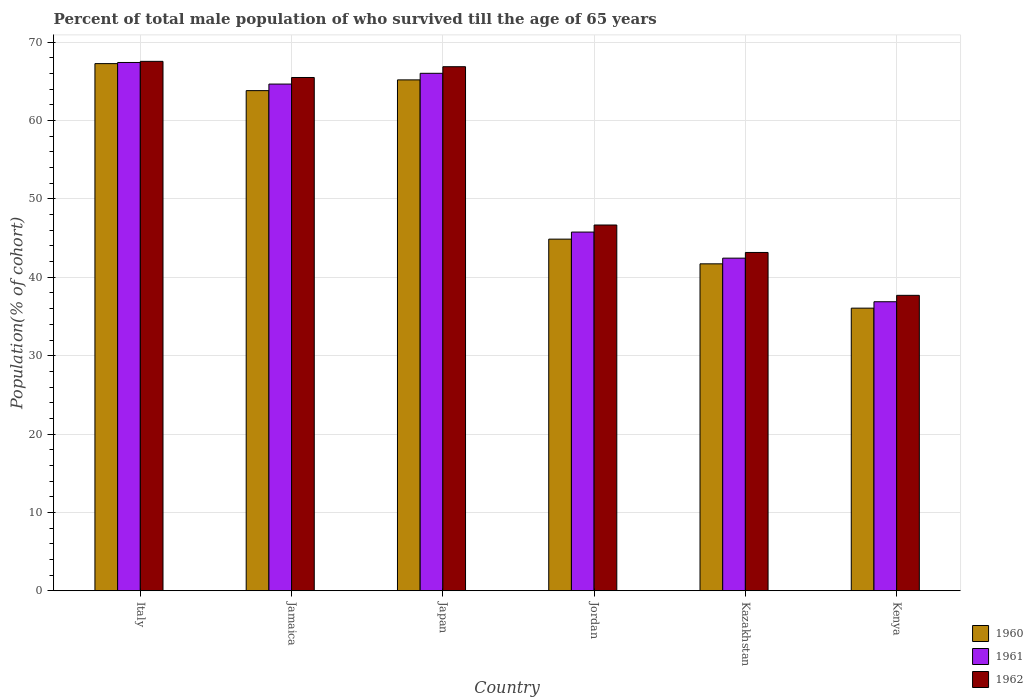Are the number of bars per tick equal to the number of legend labels?
Your response must be concise. Yes. How many bars are there on the 5th tick from the left?
Give a very brief answer. 3. How many bars are there on the 2nd tick from the right?
Provide a succinct answer. 3. What is the label of the 5th group of bars from the left?
Give a very brief answer. Kazakhstan. What is the percentage of total male population who survived till the age of 65 years in 1961 in Jamaica?
Keep it short and to the point. 64.67. Across all countries, what is the maximum percentage of total male population who survived till the age of 65 years in 1961?
Your response must be concise. 67.42. Across all countries, what is the minimum percentage of total male population who survived till the age of 65 years in 1961?
Give a very brief answer. 36.88. In which country was the percentage of total male population who survived till the age of 65 years in 1960 maximum?
Offer a terse response. Italy. In which country was the percentage of total male population who survived till the age of 65 years in 1962 minimum?
Offer a very short reply. Kenya. What is the total percentage of total male population who survived till the age of 65 years in 1960 in the graph?
Provide a succinct answer. 318.97. What is the difference between the percentage of total male population who survived till the age of 65 years in 1961 in Jordan and that in Kazakhstan?
Provide a succinct answer. 3.33. What is the difference between the percentage of total male population who survived till the age of 65 years in 1962 in Jordan and the percentage of total male population who survived till the age of 65 years in 1960 in Jamaica?
Ensure brevity in your answer.  -17.15. What is the average percentage of total male population who survived till the age of 65 years in 1961 per country?
Offer a very short reply. 53.87. What is the difference between the percentage of total male population who survived till the age of 65 years of/in 1961 and percentage of total male population who survived till the age of 65 years of/in 1962 in Jamaica?
Provide a succinct answer. -0.84. What is the ratio of the percentage of total male population who survived till the age of 65 years in 1962 in Jamaica to that in Kenya?
Your response must be concise. 1.74. Is the percentage of total male population who survived till the age of 65 years in 1960 in Italy less than that in Kazakhstan?
Your answer should be very brief. No. What is the difference between the highest and the second highest percentage of total male population who survived till the age of 65 years in 1962?
Give a very brief answer. -1.38. What is the difference between the highest and the lowest percentage of total male population who survived till the age of 65 years in 1960?
Provide a succinct answer. 31.21. In how many countries, is the percentage of total male population who survived till the age of 65 years in 1960 greater than the average percentage of total male population who survived till the age of 65 years in 1960 taken over all countries?
Keep it short and to the point. 3. Is the sum of the percentage of total male population who survived till the age of 65 years in 1960 in Italy and Jordan greater than the maximum percentage of total male population who survived till the age of 65 years in 1962 across all countries?
Your answer should be compact. Yes. What does the 3rd bar from the right in Kenya represents?
Ensure brevity in your answer.  1960. Is it the case that in every country, the sum of the percentage of total male population who survived till the age of 65 years in 1961 and percentage of total male population who survived till the age of 65 years in 1962 is greater than the percentage of total male population who survived till the age of 65 years in 1960?
Ensure brevity in your answer.  Yes. What is the difference between two consecutive major ticks on the Y-axis?
Give a very brief answer. 10. Are the values on the major ticks of Y-axis written in scientific E-notation?
Offer a very short reply. No. Does the graph contain any zero values?
Give a very brief answer. No. Does the graph contain grids?
Your response must be concise. Yes. How many legend labels are there?
Ensure brevity in your answer.  3. How are the legend labels stacked?
Give a very brief answer. Vertical. What is the title of the graph?
Offer a very short reply. Percent of total male population of who survived till the age of 65 years. What is the label or title of the Y-axis?
Offer a very short reply. Population(% of cohort). What is the Population(% of cohort) in 1960 in Italy?
Give a very brief answer. 67.28. What is the Population(% of cohort) in 1961 in Italy?
Keep it short and to the point. 67.42. What is the Population(% of cohort) of 1962 in Italy?
Your answer should be compact. 67.57. What is the Population(% of cohort) of 1960 in Jamaica?
Ensure brevity in your answer.  63.83. What is the Population(% of cohort) of 1961 in Jamaica?
Make the answer very short. 64.67. What is the Population(% of cohort) in 1962 in Jamaica?
Your answer should be very brief. 65.5. What is the Population(% of cohort) in 1960 in Japan?
Ensure brevity in your answer.  65.2. What is the Population(% of cohort) of 1961 in Japan?
Keep it short and to the point. 66.04. What is the Population(% of cohort) of 1962 in Japan?
Make the answer very short. 66.88. What is the Population(% of cohort) of 1960 in Jordan?
Offer a very short reply. 44.87. What is the Population(% of cohort) of 1961 in Jordan?
Ensure brevity in your answer.  45.78. What is the Population(% of cohort) of 1962 in Jordan?
Ensure brevity in your answer.  46.68. What is the Population(% of cohort) in 1960 in Kazakhstan?
Offer a terse response. 41.72. What is the Population(% of cohort) in 1961 in Kazakhstan?
Provide a short and direct response. 42.45. What is the Population(% of cohort) of 1962 in Kazakhstan?
Give a very brief answer. 43.17. What is the Population(% of cohort) in 1960 in Kenya?
Provide a succinct answer. 36.07. What is the Population(% of cohort) of 1961 in Kenya?
Provide a succinct answer. 36.88. What is the Population(% of cohort) of 1962 in Kenya?
Your response must be concise. 37.7. Across all countries, what is the maximum Population(% of cohort) in 1960?
Ensure brevity in your answer.  67.28. Across all countries, what is the maximum Population(% of cohort) of 1961?
Give a very brief answer. 67.42. Across all countries, what is the maximum Population(% of cohort) in 1962?
Offer a very short reply. 67.57. Across all countries, what is the minimum Population(% of cohort) in 1960?
Make the answer very short. 36.07. Across all countries, what is the minimum Population(% of cohort) of 1961?
Your answer should be very brief. 36.88. Across all countries, what is the minimum Population(% of cohort) in 1962?
Offer a terse response. 37.7. What is the total Population(% of cohort) in 1960 in the graph?
Your answer should be very brief. 318.97. What is the total Population(% of cohort) in 1961 in the graph?
Offer a terse response. 323.23. What is the total Population(% of cohort) of 1962 in the graph?
Your answer should be very brief. 327.5. What is the difference between the Population(% of cohort) of 1960 in Italy and that in Jamaica?
Ensure brevity in your answer.  3.45. What is the difference between the Population(% of cohort) of 1961 in Italy and that in Jamaica?
Give a very brief answer. 2.75. What is the difference between the Population(% of cohort) of 1962 in Italy and that in Jamaica?
Your answer should be compact. 2.06. What is the difference between the Population(% of cohort) of 1960 in Italy and that in Japan?
Keep it short and to the point. 2.08. What is the difference between the Population(% of cohort) of 1961 in Italy and that in Japan?
Offer a terse response. 1.38. What is the difference between the Population(% of cohort) in 1962 in Italy and that in Japan?
Ensure brevity in your answer.  0.68. What is the difference between the Population(% of cohort) in 1960 in Italy and that in Jordan?
Your answer should be compact. 22.4. What is the difference between the Population(% of cohort) in 1961 in Italy and that in Jordan?
Offer a very short reply. 21.64. What is the difference between the Population(% of cohort) in 1962 in Italy and that in Jordan?
Give a very brief answer. 20.89. What is the difference between the Population(% of cohort) in 1960 in Italy and that in Kazakhstan?
Keep it short and to the point. 25.55. What is the difference between the Population(% of cohort) in 1961 in Italy and that in Kazakhstan?
Keep it short and to the point. 24.97. What is the difference between the Population(% of cohort) of 1962 in Italy and that in Kazakhstan?
Ensure brevity in your answer.  24.39. What is the difference between the Population(% of cohort) in 1960 in Italy and that in Kenya?
Provide a succinct answer. 31.21. What is the difference between the Population(% of cohort) in 1961 in Italy and that in Kenya?
Provide a short and direct response. 30.54. What is the difference between the Population(% of cohort) in 1962 in Italy and that in Kenya?
Provide a short and direct response. 29.86. What is the difference between the Population(% of cohort) of 1960 in Jamaica and that in Japan?
Provide a succinct answer. -1.37. What is the difference between the Population(% of cohort) of 1961 in Jamaica and that in Japan?
Keep it short and to the point. -1.37. What is the difference between the Population(% of cohort) of 1962 in Jamaica and that in Japan?
Ensure brevity in your answer.  -1.38. What is the difference between the Population(% of cohort) in 1960 in Jamaica and that in Jordan?
Make the answer very short. 18.95. What is the difference between the Population(% of cohort) in 1961 in Jamaica and that in Jordan?
Provide a short and direct response. 18.89. What is the difference between the Population(% of cohort) in 1962 in Jamaica and that in Jordan?
Give a very brief answer. 18.83. What is the difference between the Population(% of cohort) of 1960 in Jamaica and that in Kazakhstan?
Offer a terse response. 22.11. What is the difference between the Population(% of cohort) in 1961 in Jamaica and that in Kazakhstan?
Offer a terse response. 22.22. What is the difference between the Population(% of cohort) in 1962 in Jamaica and that in Kazakhstan?
Ensure brevity in your answer.  22.33. What is the difference between the Population(% of cohort) in 1960 in Jamaica and that in Kenya?
Ensure brevity in your answer.  27.76. What is the difference between the Population(% of cohort) of 1961 in Jamaica and that in Kenya?
Offer a terse response. 27.78. What is the difference between the Population(% of cohort) of 1962 in Jamaica and that in Kenya?
Give a very brief answer. 27.8. What is the difference between the Population(% of cohort) of 1960 in Japan and that in Jordan?
Provide a short and direct response. 20.32. What is the difference between the Population(% of cohort) in 1961 in Japan and that in Jordan?
Give a very brief answer. 20.26. What is the difference between the Population(% of cohort) of 1962 in Japan and that in Jordan?
Your answer should be very brief. 20.2. What is the difference between the Population(% of cohort) in 1960 in Japan and that in Kazakhstan?
Ensure brevity in your answer.  23.48. What is the difference between the Population(% of cohort) in 1961 in Japan and that in Kazakhstan?
Your answer should be very brief. 23.59. What is the difference between the Population(% of cohort) in 1962 in Japan and that in Kazakhstan?
Your response must be concise. 23.71. What is the difference between the Population(% of cohort) in 1960 in Japan and that in Kenya?
Give a very brief answer. 29.13. What is the difference between the Population(% of cohort) in 1961 in Japan and that in Kenya?
Your answer should be very brief. 29.16. What is the difference between the Population(% of cohort) of 1962 in Japan and that in Kenya?
Your response must be concise. 29.18. What is the difference between the Population(% of cohort) in 1960 in Jordan and that in Kazakhstan?
Make the answer very short. 3.15. What is the difference between the Population(% of cohort) in 1961 in Jordan and that in Kazakhstan?
Your answer should be very brief. 3.33. What is the difference between the Population(% of cohort) in 1962 in Jordan and that in Kazakhstan?
Provide a short and direct response. 3.51. What is the difference between the Population(% of cohort) of 1960 in Jordan and that in Kenya?
Provide a succinct answer. 8.81. What is the difference between the Population(% of cohort) of 1961 in Jordan and that in Kenya?
Your response must be concise. 8.89. What is the difference between the Population(% of cohort) in 1962 in Jordan and that in Kenya?
Provide a succinct answer. 8.98. What is the difference between the Population(% of cohort) of 1960 in Kazakhstan and that in Kenya?
Keep it short and to the point. 5.66. What is the difference between the Population(% of cohort) of 1961 in Kazakhstan and that in Kenya?
Provide a short and direct response. 5.56. What is the difference between the Population(% of cohort) of 1962 in Kazakhstan and that in Kenya?
Offer a very short reply. 5.47. What is the difference between the Population(% of cohort) in 1960 in Italy and the Population(% of cohort) in 1961 in Jamaica?
Make the answer very short. 2.61. What is the difference between the Population(% of cohort) of 1960 in Italy and the Population(% of cohort) of 1962 in Jamaica?
Ensure brevity in your answer.  1.77. What is the difference between the Population(% of cohort) of 1961 in Italy and the Population(% of cohort) of 1962 in Jamaica?
Your response must be concise. 1.92. What is the difference between the Population(% of cohort) of 1960 in Italy and the Population(% of cohort) of 1961 in Japan?
Provide a succinct answer. 1.24. What is the difference between the Population(% of cohort) of 1960 in Italy and the Population(% of cohort) of 1962 in Japan?
Make the answer very short. 0.4. What is the difference between the Population(% of cohort) of 1961 in Italy and the Population(% of cohort) of 1962 in Japan?
Give a very brief answer. 0.54. What is the difference between the Population(% of cohort) of 1960 in Italy and the Population(% of cohort) of 1961 in Jordan?
Your answer should be very brief. 21.5. What is the difference between the Population(% of cohort) in 1960 in Italy and the Population(% of cohort) in 1962 in Jordan?
Provide a succinct answer. 20.6. What is the difference between the Population(% of cohort) of 1961 in Italy and the Population(% of cohort) of 1962 in Jordan?
Your answer should be compact. 20.74. What is the difference between the Population(% of cohort) of 1960 in Italy and the Population(% of cohort) of 1961 in Kazakhstan?
Offer a terse response. 24.83. What is the difference between the Population(% of cohort) of 1960 in Italy and the Population(% of cohort) of 1962 in Kazakhstan?
Make the answer very short. 24.1. What is the difference between the Population(% of cohort) in 1961 in Italy and the Population(% of cohort) in 1962 in Kazakhstan?
Your answer should be compact. 24.25. What is the difference between the Population(% of cohort) in 1960 in Italy and the Population(% of cohort) in 1961 in Kenya?
Make the answer very short. 30.39. What is the difference between the Population(% of cohort) of 1960 in Italy and the Population(% of cohort) of 1962 in Kenya?
Ensure brevity in your answer.  29.57. What is the difference between the Population(% of cohort) in 1961 in Italy and the Population(% of cohort) in 1962 in Kenya?
Your answer should be very brief. 29.72. What is the difference between the Population(% of cohort) of 1960 in Jamaica and the Population(% of cohort) of 1961 in Japan?
Your response must be concise. -2.21. What is the difference between the Population(% of cohort) in 1960 in Jamaica and the Population(% of cohort) in 1962 in Japan?
Offer a very short reply. -3.05. What is the difference between the Population(% of cohort) of 1961 in Jamaica and the Population(% of cohort) of 1962 in Japan?
Make the answer very short. -2.21. What is the difference between the Population(% of cohort) in 1960 in Jamaica and the Population(% of cohort) in 1961 in Jordan?
Make the answer very short. 18.05. What is the difference between the Population(% of cohort) of 1960 in Jamaica and the Population(% of cohort) of 1962 in Jordan?
Keep it short and to the point. 17.15. What is the difference between the Population(% of cohort) of 1961 in Jamaica and the Population(% of cohort) of 1962 in Jordan?
Offer a terse response. 17.99. What is the difference between the Population(% of cohort) of 1960 in Jamaica and the Population(% of cohort) of 1961 in Kazakhstan?
Provide a short and direct response. 21.38. What is the difference between the Population(% of cohort) of 1960 in Jamaica and the Population(% of cohort) of 1962 in Kazakhstan?
Keep it short and to the point. 20.66. What is the difference between the Population(% of cohort) of 1961 in Jamaica and the Population(% of cohort) of 1962 in Kazakhstan?
Give a very brief answer. 21.49. What is the difference between the Population(% of cohort) in 1960 in Jamaica and the Population(% of cohort) in 1961 in Kenya?
Make the answer very short. 26.94. What is the difference between the Population(% of cohort) of 1960 in Jamaica and the Population(% of cohort) of 1962 in Kenya?
Give a very brief answer. 26.13. What is the difference between the Population(% of cohort) in 1961 in Jamaica and the Population(% of cohort) in 1962 in Kenya?
Offer a very short reply. 26.96. What is the difference between the Population(% of cohort) in 1960 in Japan and the Population(% of cohort) in 1961 in Jordan?
Keep it short and to the point. 19.42. What is the difference between the Population(% of cohort) of 1960 in Japan and the Population(% of cohort) of 1962 in Jordan?
Provide a short and direct response. 18.52. What is the difference between the Population(% of cohort) of 1961 in Japan and the Population(% of cohort) of 1962 in Jordan?
Provide a succinct answer. 19.36. What is the difference between the Population(% of cohort) in 1960 in Japan and the Population(% of cohort) in 1961 in Kazakhstan?
Your response must be concise. 22.75. What is the difference between the Population(% of cohort) of 1960 in Japan and the Population(% of cohort) of 1962 in Kazakhstan?
Offer a terse response. 22.03. What is the difference between the Population(% of cohort) in 1961 in Japan and the Population(% of cohort) in 1962 in Kazakhstan?
Your answer should be very brief. 22.87. What is the difference between the Population(% of cohort) of 1960 in Japan and the Population(% of cohort) of 1961 in Kenya?
Keep it short and to the point. 28.32. What is the difference between the Population(% of cohort) of 1960 in Japan and the Population(% of cohort) of 1962 in Kenya?
Offer a terse response. 27.5. What is the difference between the Population(% of cohort) of 1961 in Japan and the Population(% of cohort) of 1962 in Kenya?
Provide a succinct answer. 28.34. What is the difference between the Population(% of cohort) in 1960 in Jordan and the Population(% of cohort) in 1961 in Kazakhstan?
Provide a succinct answer. 2.43. What is the difference between the Population(% of cohort) in 1960 in Jordan and the Population(% of cohort) in 1962 in Kazakhstan?
Your answer should be very brief. 1.7. What is the difference between the Population(% of cohort) of 1961 in Jordan and the Population(% of cohort) of 1962 in Kazakhstan?
Keep it short and to the point. 2.6. What is the difference between the Population(% of cohort) of 1960 in Jordan and the Population(% of cohort) of 1961 in Kenya?
Your answer should be very brief. 7.99. What is the difference between the Population(% of cohort) of 1960 in Jordan and the Population(% of cohort) of 1962 in Kenya?
Make the answer very short. 7.17. What is the difference between the Population(% of cohort) in 1961 in Jordan and the Population(% of cohort) in 1962 in Kenya?
Your answer should be compact. 8.07. What is the difference between the Population(% of cohort) in 1960 in Kazakhstan and the Population(% of cohort) in 1961 in Kenya?
Provide a short and direct response. 4.84. What is the difference between the Population(% of cohort) in 1960 in Kazakhstan and the Population(% of cohort) in 1962 in Kenya?
Ensure brevity in your answer.  4.02. What is the difference between the Population(% of cohort) in 1961 in Kazakhstan and the Population(% of cohort) in 1962 in Kenya?
Provide a succinct answer. 4.75. What is the average Population(% of cohort) in 1960 per country?
Your answer should be compact. 53.16. What is the average Population(% of cohort) of 1961 per country?
Offer a terse response. 53.87. What is the average Population(% of cohort) of 1962 per country?
Ensure brevity in your answer.  54.58. What is the difference between the Population(% of cohort) of 1960 and Population(% of cohort) of 1961 in Italy?
Keep it short and to the point. -0.14. What is the difference between the Population(% of cohort) in 1960 and Population(% of cohort) in 1962 in Italy?
Your answer should be compact. -0.29. What is the difference between the Population(% of cohort) in 1961 and Population(% of cohort) in 1962 in Italy?
Offer a terse response. -0.14. What is the difference between the Population(% of cohort) in 1960 and Population(% of cohort) in 1961 in Jamaica?
Keep it short and to the point. -0.84. What is the difference between the Population(% of cohort) in 1960 and Population(% of cohort) in 1962 in Jamaica?
Provide a short and direct response. -1.68. What is the difference between the Population(% of cohort) in 1961 and Population(% of cohort) in 1962 in Jamaica?
Your answer should be very brief. -0.84. What is the difference between the Population(% of cohort) of 1960 and Population(% of cohort) of 1961 in Japan?
Ensure brevity in your answer.  -0.84. What is the difference between the Population(% of cohort) of 1960 and Population(% of cohort) of 1962 in Japan?
Give a very brief answer. -1.68. What is the difference between the Population(% of cohort) of 1961 and Population(% of cohort) of 1962 in Japan?
Your answer should be very brief. -0.84. What is the difference between the Population(% of cohort) in 1960 and Population(% of cohort) in 1961 in Jordan?
Give a very brief answer. -0.9. What is the difference between the Population(% of cohort) of 1960 and Population(% of cohort) of 1962 in Jordan?
Your answer should be very brief. -1.8. What is the difference between the Population(% of cohort) in 1961 and Population(% of cohort) in 1962 in Jordan?
Make the answer very short. -0.9. What is the difference between the Population(% of cohort) of 1960 and Population(% of cohort) of 1961 in Kazakhstan?
Keep it short and to the point. -0.73. What is the difference between the Population(% of cohort) in 1960 and Population(% of cohort) in 1962 in Kazakhstan?
Ensure brevity in your answer.  -1.45. What is the difference between the Population(% of cohort) in 1961 and Population(% of cohort) in 1962 in Kazakhstan?
Provide a succinct answer. -0.73. What is the difference between the Population(% of cohort) of 1960 and Population(% of cohort) of 1961 in Kenya?
Your answer should be compact. -0.82. What is the difference between the Population(% of cohort) of 1960 and Population(% of cohort) of 1962 in Kenya?
Make the answer very short. -1.64. What is the difference between the Population(% of cohort) in 1961 and Population(% of cohort) in 1962 in Kenya?
Make the answer very short. -0.82. What is the ratio of the Population(% of cohort) in 1960 in Italy to that in Jamaica?
Ensure brevity in your answer.  1.05. What is the ratio of the Population(% of cohort) in 1961 in Italy to that in Jamaica?
Offer a terse response. 1.04. What is the ratio of the Population(% of cohort) of 1962 in Italy to that in Jamaica?
Ensure brevity in your answer.  1.03. What is the ratio of the Population(% of cohort) of 1960 in Italy to that in Japan?
Your answer should be very brief. 1.03. What is the ratio of the Population(% of cohort) in 1961 in Italy to that in Japan?
Provide a short and direct response. 1.02. What is the ratio of the Population(% of cohort) in 1962 in Italy to that in Japan?
Keep it short and to the point. 1.01. What is the ratio of the Population(% of cohort) in 1960 in Italy to that in Jordan?
Your answer should be very brief. 1.5. What is the ratio of the Population(% of cohort) of 1961 in Italy to that in Jordan?
Your answer should be compact. 1.47. What is the ratio of the Population(% of cohort) in 1962 in Italy to that in Jordan?
Ensure brevity in your answer.  1.45. What is the ratio of the Population(% of cohort) in 1960 in Italy to that in Kazakhstan?
Offer a terse response. 1.61. What is the ratio of the Population(% of cohort) in 1961 in Italy to that in Kazakhstan?
Keep it short and to the point. 1.59. What is the ratio of the Population(% of cohort) in 1962 in Italy to that in Kazakhstan?
Give a very brief answer. 1.56. What is the ratio of the Population(% of cohort) in 1960 in Italy to that in Kenya?
Your response must be concise. 1.87. What is the ratio of the Population(% of cohort) of 1961 in Italy to that in Kenya?
Ensure brevity in your answer.  1.83. What is the ratio of the Population(% of cohort) in 1962 in Italy to that in Kenya?
Provide a short and direct response. 1.79. What is the ratio of the Population(% of cohort) of 1960 in Jamaica to that in Japan?
Your answer should be compact. 0.98. What is the ratio of the Population(% of cohort) of 1961 in Jamaica to that in Japan?
Provide a succinct answer. 0.98. What is the ratio of the Population(% of cohort) in 1962 in Jamaica to that in Japan?
Offer a very short reply. 0.98. What is the ratio of the Population(% of cohort) in 1960 in Jamaica to that in Jordan?
Provide a succinct answer. 1.42. What is the ratio of the Population(% of cohort) in 1961 in Jamaica to that in Jordan?
Keep it short and to the point. 1.41. What is the ratio of the Population(% of cohort) of 1962 in Jamaica to that in Jordan?
Your answer should be very brief. 1.4. What is the ratio of the Population(% of cohort) of 1960 in Jamaica to that in Kazakhstan?
Make the answer very short. 1.53. What is the ratio of the Population(% of cohort) in 1961 in Jamaica to that in Kazakhstan?
Give a very brief answer. 1.52. What is the ratio of the Population(% of cohort) in 1962 in Jamaica to that in Kazakhstan?
Give a very brief answer. 1.52. What is the ratio of the Population(% of cohort) of 1960 in Jamaica to that in Kenya?
Offer a very short reply. 1.77. What is the ratio of the Population(% of cohort) of 1961 in Jamaica to that in Kenya?
Your response must be concise. 1.75. What is the ratio of the Population(% of cohort) in 1962 in Jamaica to that in Kenya?
Your answer should be compact. 1.74. What is the ratio of the Population(% of cohort) in 1960 in Japan to that in Jordan?
Your answer should be compact. 1.45. What is the ratio of the Population(% of cohort) of 1961 in Japan to that in Jordan?
Your answer should be very brief. 1.44. What is the ratio of the Population(% of cohort) of 1962 in Japan to that in Jordan?
Ensure brevity in your answer.  1.43. What is the ratio of the Population(% of cohort) in 1960 in Japan to that in Kazakhstan?
Your answer should be compact. 1.56. What is the ratio of the Population(% of cohort) of 1961 in Japan to that in Kazakhstan?
Provide a succinct answer. 1.56. What is the ratio of the Population(% of cohort) in 1962 in Japan to that in Kazakhstan?
Your response must be concise. 1.55. What is the ratio of the Population(% of cohort) in 1960 in Japan to that in Kenya?
Provide a succinct answer. 1.81. What is the ratio of the Population(% of cohort) of 1961 in Japan to that in Kenya?
Your answer should be very brief. 1.79. What is the ratio of the Population(% of cohort) of 1962 in Japan to that in Kenya?
Give a very brief answer. 1.77. What is the ratio of the Population(% of cohort) of 1960 in Jordan to that in Kazakhstan?
Provide a succinct answer. 1.08. What is the ratio of the Population(% of cohort) in 1961 in Jordan to that in Kazakhstan?
Make the answer very short. 1.08. What is the ratio of the Population(% of cohort) in 1962 in Jordan to that in Kazakhstan?
Provide a succinct answer. 1.08. What is the ratio of the Population(% of cohort) in 1960 in Jordan to that in Kenya?
Your answer should be compact. 1.24. What is the ratio of the Population(% of cohort) in 1961 in Jordan to that in Kenya?
Make the answer very short. 1.24. What is the ratio of the Population(% of cohort) of 1962 in Jordan to that in Kenya?
Give a very brief answer. 1.24. What is the ratio of the Population(% of cohort) of 1960 in Kazakhstan to that in Kenya?
Your answer should be very brief. 1.16. What is the ratio of the Population(% of cohort) of 1961 in Kazakhstan to that in Kenya?
Your response must be concise. 1.15. What is the ratio of the Population(% of cohort) of 1962 in Kazakhstan to that in Kenya?
Give a very brief answer. 1.15. What is the difference between the highest and the second highest Population(% of cohort) of 1960?
Your response must be concise. 2.08. What is the difference between the highest and the second highest Population(% of cohort) in 1961?
Offer a terse response. 1.38. What is the difference between the highest and the second highest Population(% of cohort) of 1962?
Your answer should be compact. 0.68. What is the difference between the highest and the lowest Population(% of cohort) of 1960?
Your answer should be very brief. 31.21. What is the difference between the highest and the lowest Population(% of cohort) of 1961?
Your answer should be compact. 30.54. What is the difference between the highest and the lowest Population(% of cohort) of 1962?
Your answer should be very brief. 29.86. 